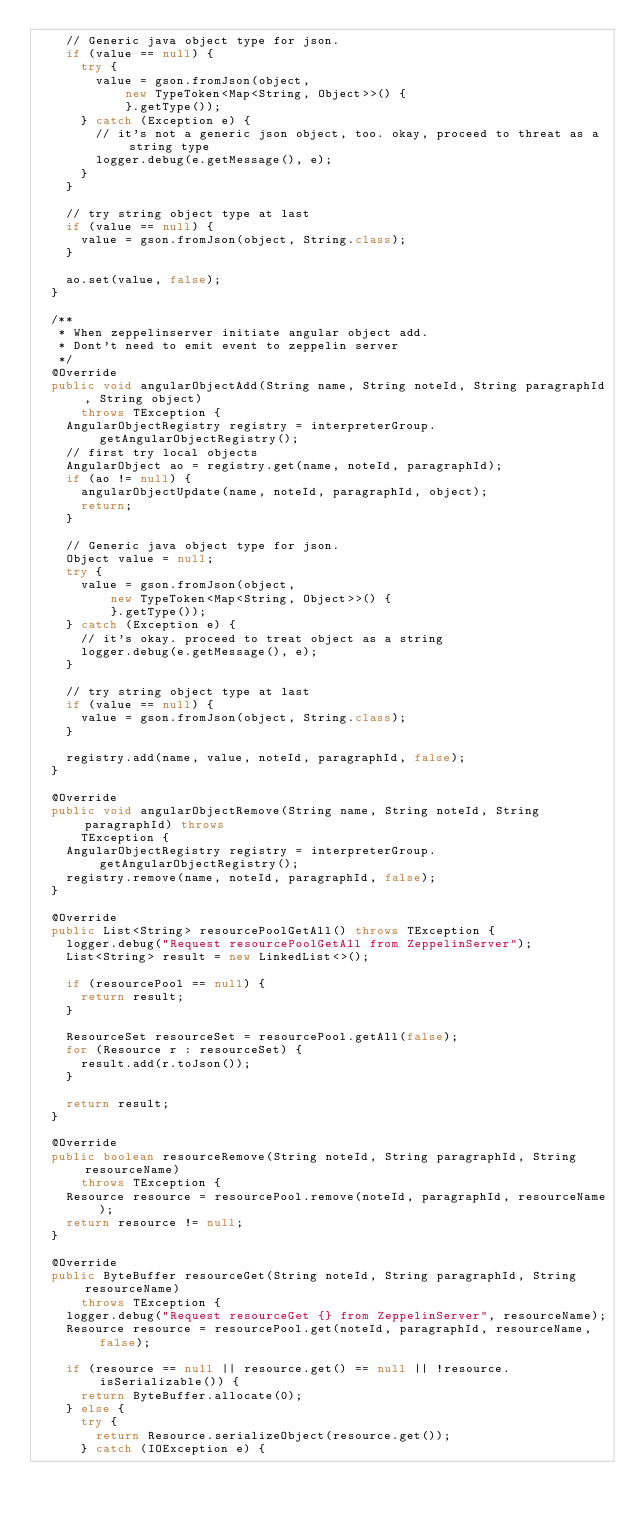<code> <loc_0><loc_0><loc_500><loc_500><_Java_>    // Generic java object type for json.
    if (value == null) {
      try {
        value = gson.fromJson(object,
            new TypeToken<Map<String, Object>>() {
            }.getType());
      } catch (Exception e) {
        // it's not a generic json object, too. okay, proceed to threat as a string type
        logger.debug(e.getMessage(), e);
      }
    }

    // try string object type at last
    if (value == null) {
      value = gson.fromJson(object, String.class);
    }

    ao.set(value, false);
  }

  /**
   * When zeppelinserver initiate angular object add.
   * Dont't need to emit event to zeppelin server
   */
  @Override
  public void angularObjectAdd(String name, String noteId, String paragraphId, String object)
      throws TException {
    AngularObjectRegistry registry = interpreterGroup.getAngularObjectRegistry();
    // first try local objects
    AngularObject ao = registry.get(name, noteId, paragraphId);
    if (ao != null) {
      angularObjectUpdate(name, noteId, paragraphId, object);
      return;
    }

    // Generic java object type for json.
    Object value = null;
    try {
      value = gson.fromJson(object,
          new TypeToken<Map<String, Object>>() {
          }.getType());
    } catch (Exception e) {
      // it's okay. proceed to treat object as a string
      logger.debug(e.getMessage(), e);
    }

    // try string object type at last
    if (value == null) {
      value = gson.fromJson(object, String.class);
    }

    registry.add(name, value, noteId, paragraphId, false);
  }

  @Override
  public void angularObjectRemove(String name, String noteId, String paragraphId) throws
      TException {
    AngularObjectRegistry registry = interpreterGroup.getAngularObjectRegistry();
    registry.remove(name, noteId, paragraphId, false);
  }

  @Override
  public List<String> resourcePoolGetAll() throws TException {
    logger.debug("Request resourcePoolGetAll from ZeppelinServer");
    List<String> result = new LinkedList<>();

    if (resourcePool == null) {
      return result;
    }

    ResourceSet resourceSet = resourcePool.getAll(false);
    for (Resource r : resourceSet) {
      result.add(r.toJson());
    }

    return result;
  }

  @Override
  public boolean resourceRemove(String noteId, String paragraphId, String resourceName)
      throws TException {
    Resource resource = resourcePool.remove(noteId, paragraphId, resourceName);
    return resource != null;
  }

  @Override
  public ByteBuffer resourceGet(String noteId, String paragraphId, String resourceName)
      throws TException {
    logger.debug("Request resourceGet {} from ZeppelinServer", resourceName);
    Resource resource = resourcePool.get(noteId, paragraphId, resourceName, false);

    if (resource == null || resource.get() == null || !resource.isSerializable()) {
      return ByteBuffer.allocate(0);
    } else {
      try {
        return Resource.serializeObject(resource.get());
      } catch (IOException e) {</code> 